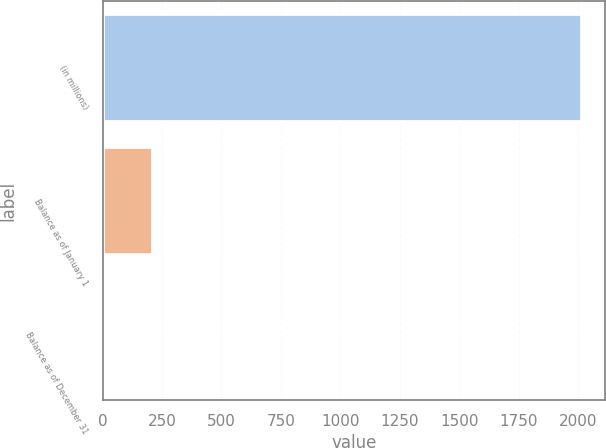Convert chart to OTSL. <chart><loc_0><loc_0><loc_500><loc_500><bar_chart><fcel>(in millions)<fcel>Balance as of January 1<fcel>Balance as of December 31<nl><fcel>2013<fcel>205.8<fcel>5<nl></chart> 